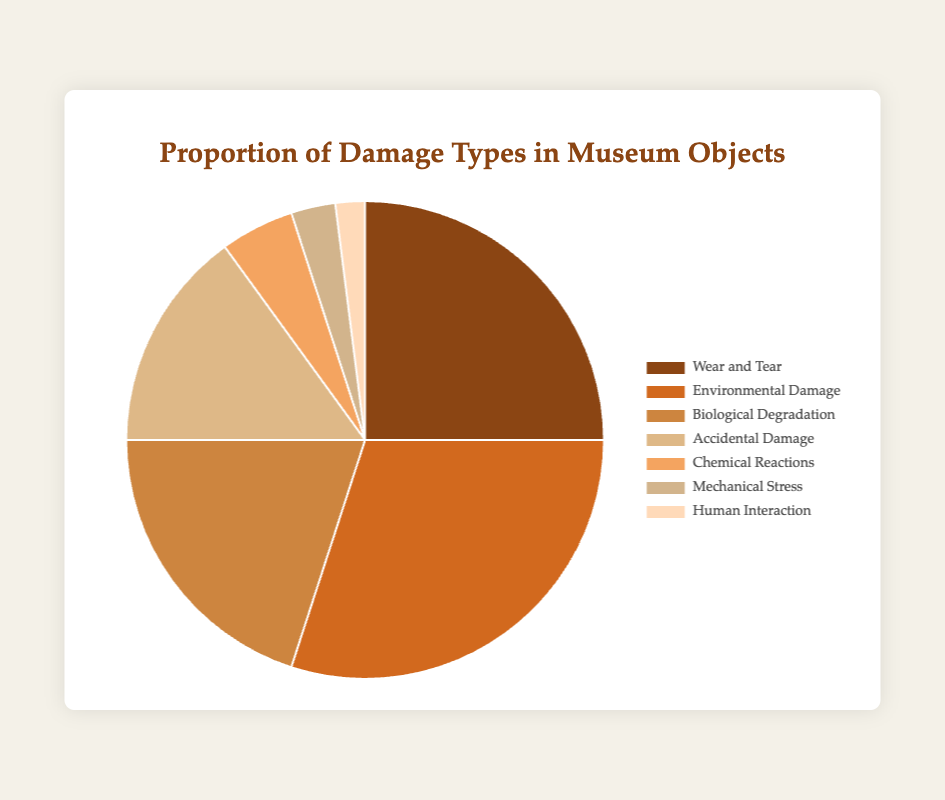What type of damage has the highest proportion in the museum objects? By looking at the pie chart, the segment with the largest size represents the type of damage with the highest proportion. The "Environmental Damage" segment is the largest one.
Answer: Environmental Damage What is the combined proportion of Wear and Tear and Biological Degradation? Add the proportions of Wear and Tear and Biological Degradation from the data: 25% (Wear and Tear) + 20% (Biological Degradation) = 45%.
Answer: 45% Which type of damage has the smallest proportion? Identify the smallest segment in the pie chart, which represents the type of damage with the lowest proportion. The "Human Interaction" segment is the smallest one.
Answer: Human Interaction How much larger is the proportion of Environmental Damage compared to Mechanical Stress? Subtract the proportion of Mechanical Stress from the proportion of Environmental Damage: 30% (Environmental Damage) - 3% (Mechanical Stress) = 27%.
Answer: 27% Which types of damage together constitute more than 50% of the total damage? Identify the combinations of damage types that add up to over 50%. "Environmental Damage" (30%) and "Wear and Tear" (25%) together constitute 55%.
Answer: Environmental Damage and Wear and Tear What is the proportion difference between Wear and Tear and Accidental Damage? Subtract the proportion of Accidental Damage from the proportion of Wear and Tear: 25% (Wear and Tear) - 15% (Accidental Damage) = 10%.
Answer: 10% Are Biological Degradation and Accidental Damage proportions combined greater than Environmental Damage proportion? Add the proportions of Biological Degradation and Accidental Damage: 20% (Biological Degradation) + 15% (Accidental Damage) = 35%. Compare it with Environmental Damage (30%). 35% is greater than 30%.
Answer: Yes Which segments of the chart are represented with warm colors like shades of red and orange? Visually identify the segments with warm colors. These are "Environmental Damage," "Biological Degradation," and "Accidental Damage" represented by shades of brown and orange.
Answer: Environmental Damage, Biological Degradation, andAccidental Damage What is the proportion difference between the largest and smallest damage categories? Subtract the proportion of Human Interaction from Environmental Damage: 30% (Environmental Damage) - 2% (Human Interaction) = 28%.
Answer: 28% How many types of damage have a proportion greater than 20%? Count the segments with proportions over 20%. They are: "Wear and Tear" (25%), "Environmental Damage" (30%), and "Biological Degradation" (20%) - 3 types.
Answer: 3 